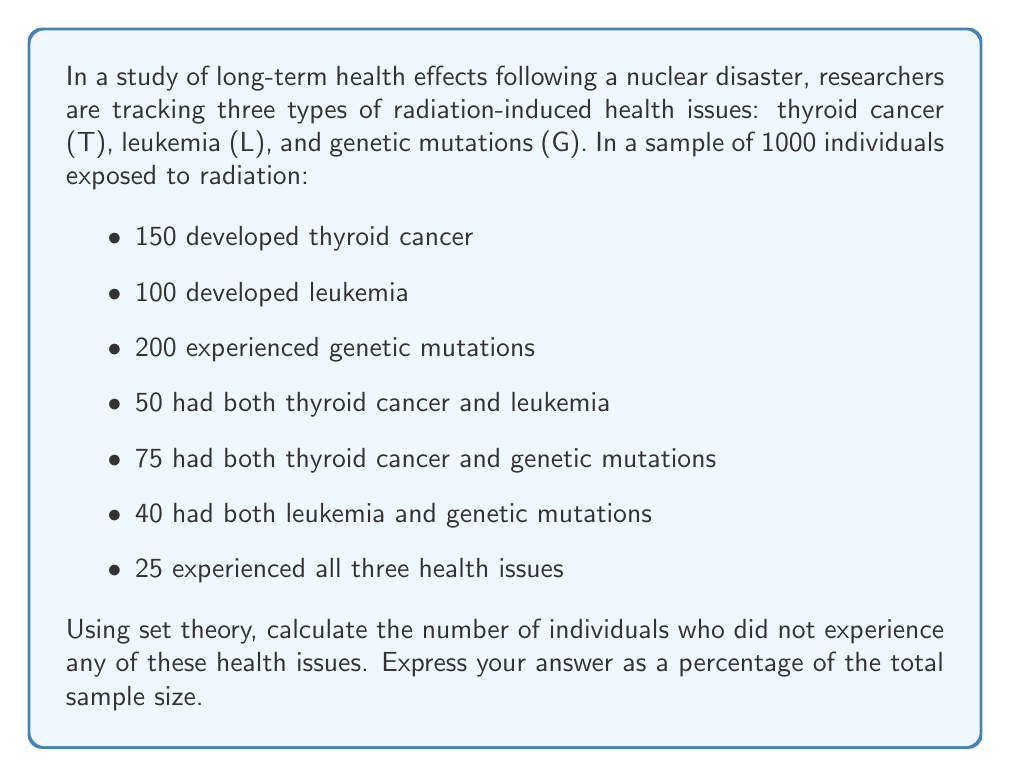What is the answer to this math problem? To solve this problem, we'll use the principle of inclusion-exclusion from set theory. Let's break it down step by step:

1) First, let's define our sets:
   T: individuals with thyroid cancer
   L: individuals with leukemia
   G: individuals with genetic mutations

2) We're given the following information:
   $|T| = 150$, $|L| = 100$, $|G| = 200$
   $|T \cap L| = 50$, $|T \cap G| = 75$, $|L \cap G| = 40$
   $|T \cap L \cap G| = 25$

3) We need to find $|T \cup L \cup G|$, which represents the total number of individuals affected by at least one health issue.

4) The inclusion-exclusion principle states:

   $$|T \cup L \cup G| = |T| + |L| + |G| - |T \cap L| - |T \cap G| - |L \cap G| + |T \cap L \cap G|$$

5) Substituting our known values:

   $$|T \cup L \cup G| = 150 + 100 + 200 - 50 - 75 - 40 + 25 = 310$$

6) This means 310 individuals experienced at least one health issue.

7) The number of individuals who didn't experience any health issues is:

   $$1000 - 310 = 690$$

8) To express this as a percentage:

   $$\frac{690}{1000} \times 100\% = 69\%$$
Answer: 69% 